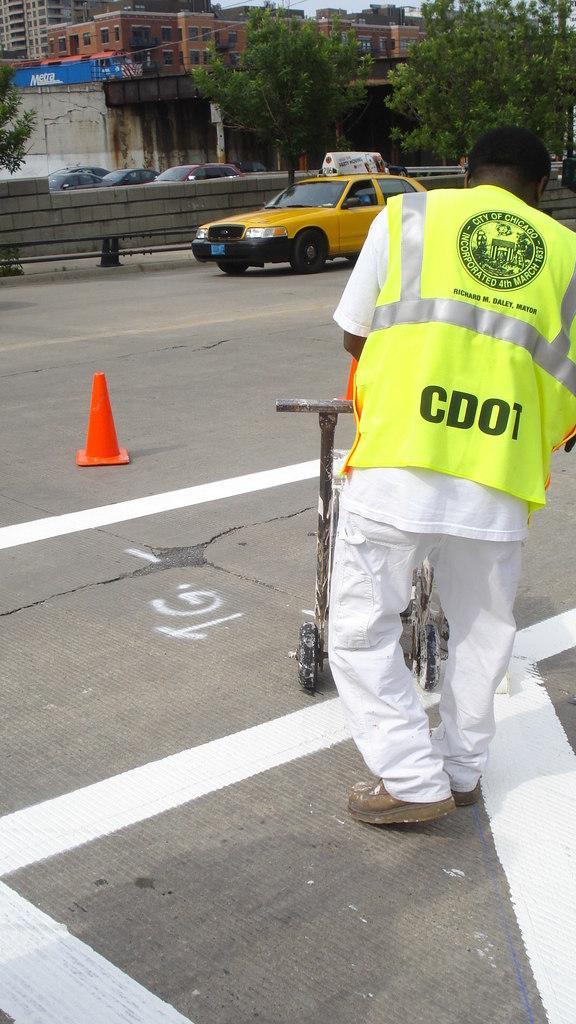How would you summarize this image in a sentence or two? In this picture we can observe a person standing, wearing a green color coat. We can observe an orange color traffic cone on the road. There is a yellow color car. In the background there are trees and buildings. 